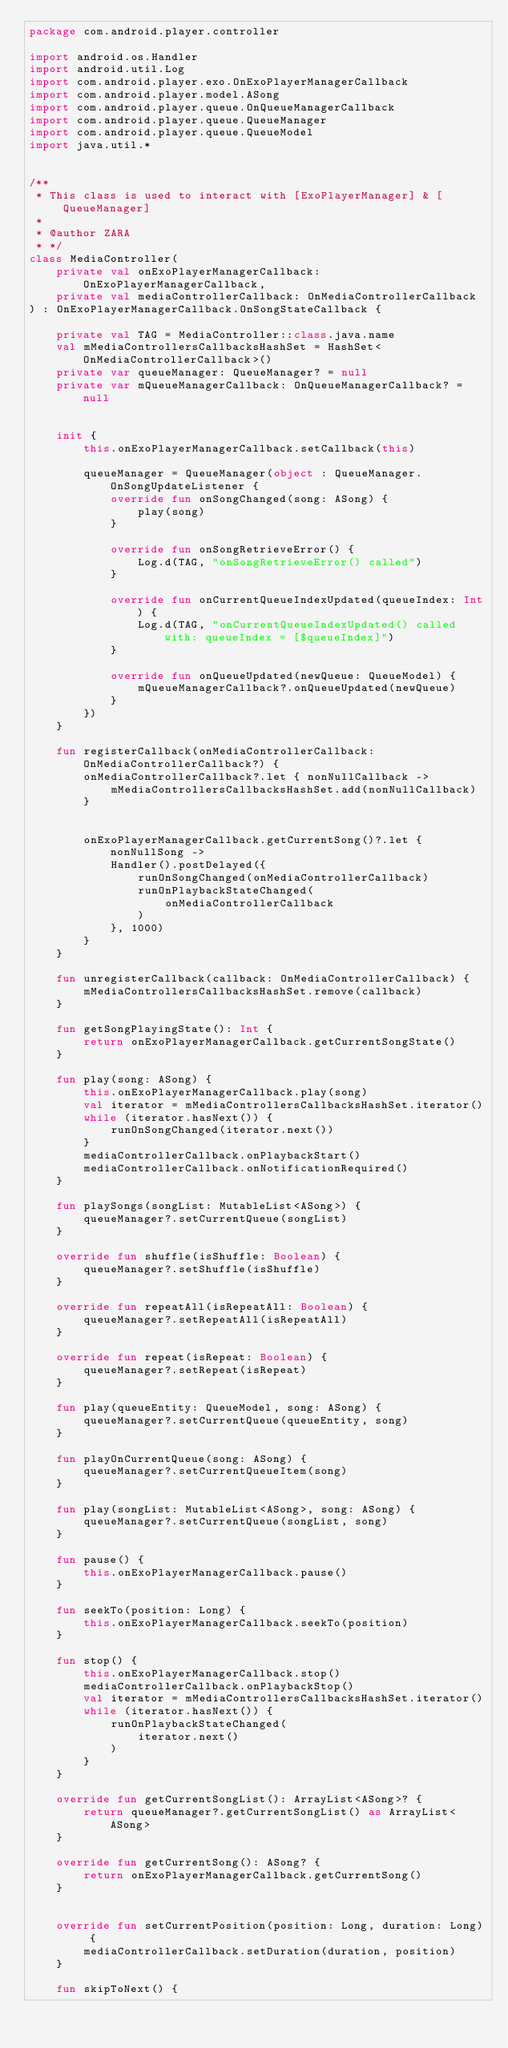<code> <loc_0><loc_0><loc_500><loc_500><_Kotlin_>package com.android.player.controller

import android.os.Handler
import android.util.Log
import com.android.player.exo.OnExoPlayerManagerCallback
import com.android.player.model.ASong
import com.android.player.queue.OnQueueManagerCallback
import com.android.player.queue.QueueManager
import com.android.player.queue.QueueModel
import java.util.*


/**
 * This class is used to interact with [ExoPlayerManager] & [QueueManager]
 *
 * @author ZARA
 * */
class MediaController(
    private val onExoPlayerManagerCallback: OnExoPlayerManagerCallback,
    private val mediaControllerCallback: OnMediaControllerCallback
) : OnExoPlayerManagerCallback.OnSongStateCallback {

    private val TAG = MediaController::class.java.name
    val mMediaControllersCallbacksHashSet = HashSet<OnMediaControllerCallback>()
    private var queueManager: QueueManager? = null
    private var mQueueManagerCallback: OnQueueManagerCallback? = null


    init {
        this.onExoPlayerManagerCallback.setCallback(this)

        queueManager = QueueManager(object : QueueManager.OnSongUpdateListener {
            override fun onSongChanged(song: ASong) {
                play(song)
            }

            override fun onSongRetrieveError() {
                Log.d(TAG, "onSongRetrieveError() called")
            }

            override fun onCurrentQueueIndexUpdated(queueIndex: Int) {
                Log.d(TAG, "onCurrentQueueIndexUpdated() called with: queueIndex = [$queueIndex]")
            }

            override fun onQueueUpdated(newQueue: QueueModel) {
                mQueueManagerCallback?.onQueueUpdated(newQueue)
            }
        })
    }

    fun registerCallback(onMediaControllerCallback: OnMediaControllerCallback?) {
        onMediaControllerCallback?.let { nonNullCallback ->
            mMediaControllersCallbacksHashSet.add(nonNullCallback)
        }


        onExoPlayerManagerCallback.getCurrentSong()?.let { nonNullSong ->
            Handler().postDelayed({
                runOnSongChanged(onMediaControllerCallback)
                runOnPlaybackStateChanged(
                    onMediaControllerCallback
                )
            }, 1000)
        }
    }

    fun unregisterCallback(callback: OnMediaControllerCallback) {
        mMediaControllersCallbacksHashSet.remove(callback)
    }

    fun getSongPlayingState(): Int {
        return onExoPlayerManagerCallback.getCurrentSongState()
    }

    fun play(song: ASong) {
        this.onExoPlayerManagerCallback.play(song)
        val iterator = mMediaControllersCallbacksHashSet.iterator()
        while (iterator.hasNext()) {
            runOnSongChanged(iterator.next())
        }
        mediaControllerCallback.onPlaybackStart()
        mediaControllerCallback.onNotificationRequired()
    }

    fun playSongs(songList: MutableList<ASong>) {
        queueManager?.setCurrentQueue(songList)
    }

    override fun shuffle(isShuffle: Boolean) {
        queueManager?.setShuffle(isShuffle)
    }

    override fun repeatAll(isRepeatAll: Boolean) {
        queueManager?.setRepeatAll(isRepeatAll)
    }

    override fun repeat(isRepeat: Boolean) {
        queueManager?.setRepeat(isRepeat)
    }

    fun play(queueEntity: QueueModel, song: ASong) {
        queueManager?.setCurrentQueue(queueEntity, song)
    }

    fun playOnCurrentQueue(song: ASong) {
        queueManager?.setCurrentQueueItem(song)
    }

    fun play(songList: MutableList<ASong>, song: ASong) {
        queueManager?.setCurrentQueue(songList, song)
    }

    fun pause() {
        this.onExoPlayerManagerCallback.pause()
    }

    fun seekTo(position: Long) {
        this.onExoPlayerManagerCallback.seekTo(position)
    }

    fun stop() {
        this.onExoPlayerManagerCallback.stop()
        mediaControllerCallback.onPlaybackStop()
        val iterator = mMediaControllersCallbacksHashSet.iterator()
        while (iterator.hasNext()) {
            runOnPlaybackStateChanged(
                iterator.next()
            )
        }
    }

    override fun getCurrentSongList(): ArrayList<ASong>? {
        return queueManager?.getCurrentSongList() as ArrayList<ASong>
    }

    override fun getCurrentSong(): ASong? {
        return onExoPlayerManagerCallback.getCurrentSong()
    }


    override fun setCurrentPosition(position: Long, duration: Long) {
        mediaControllerCallback.setDuration(duration, position)
    }

    fun skipToNext() {</code> 